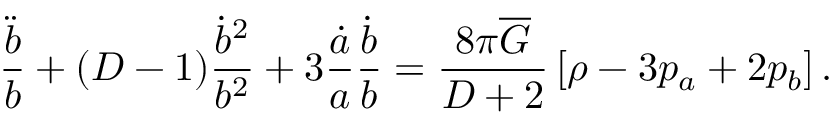Convert formula to latex. <formula><loc_0><loc_0><loc_500><loc_500>\frac { \ddot { b } } { b } + ( D - 1 ) \frac { \dot { b } ^ { 2 } } { b ^ { 2 } } + 3 \frac { \dot { a } } { a } \frac { \dot { b } } { b } = \frac { 8 \pi \overline { G } } { D + 2 } \left [ \rho - 3 p _ { a } + 2 p _ { b } \right ] .</formula> 